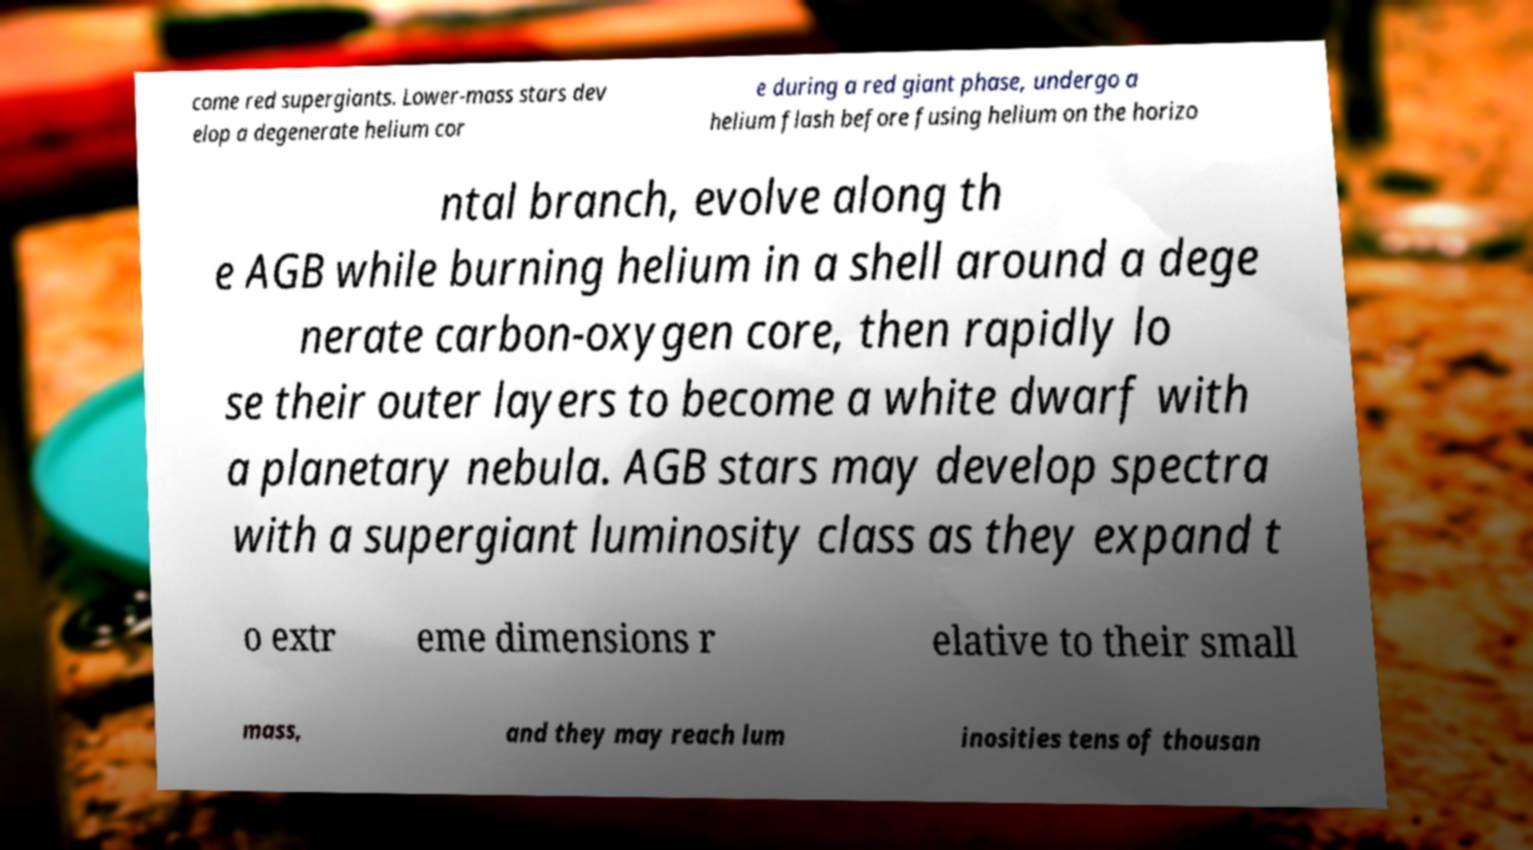For documentation purposes, I need the text within this image transcribed. Could you provide that? come red supergiants. Lower-mass stars dev elop a degenerate helium cor e during a red giant phase, undergo a helium flash before fusing helium on the horizo ntal branch, evolve along th e AGB while burning helium in a shell around a dege nerate carbon-oxygen core, then rapidly lo se their outer layers to become a white dwarf with a planetary nebula. AGB stars may develop spectra with a supergiant luminosity class as they expand t o extr eme dimensions r elative to their small mass, and they may reach lum inosities tens of thousan 